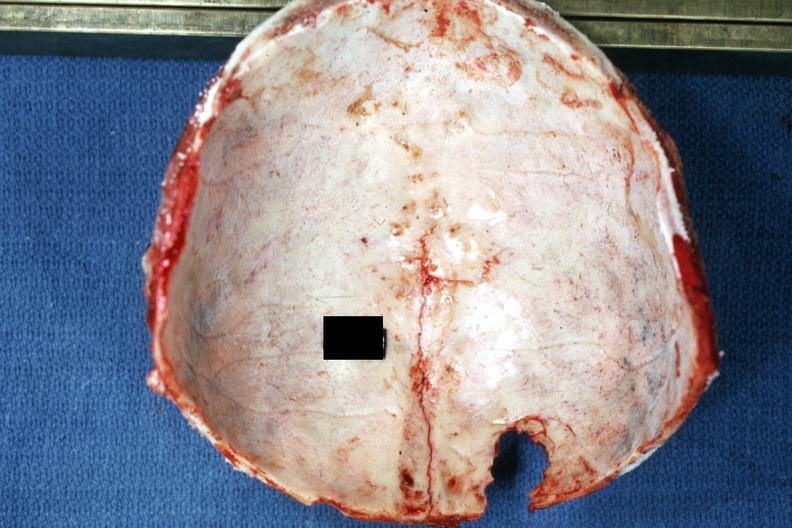s linear fracture in occiput present?
Answer the question using a single word or phrase. Yes 